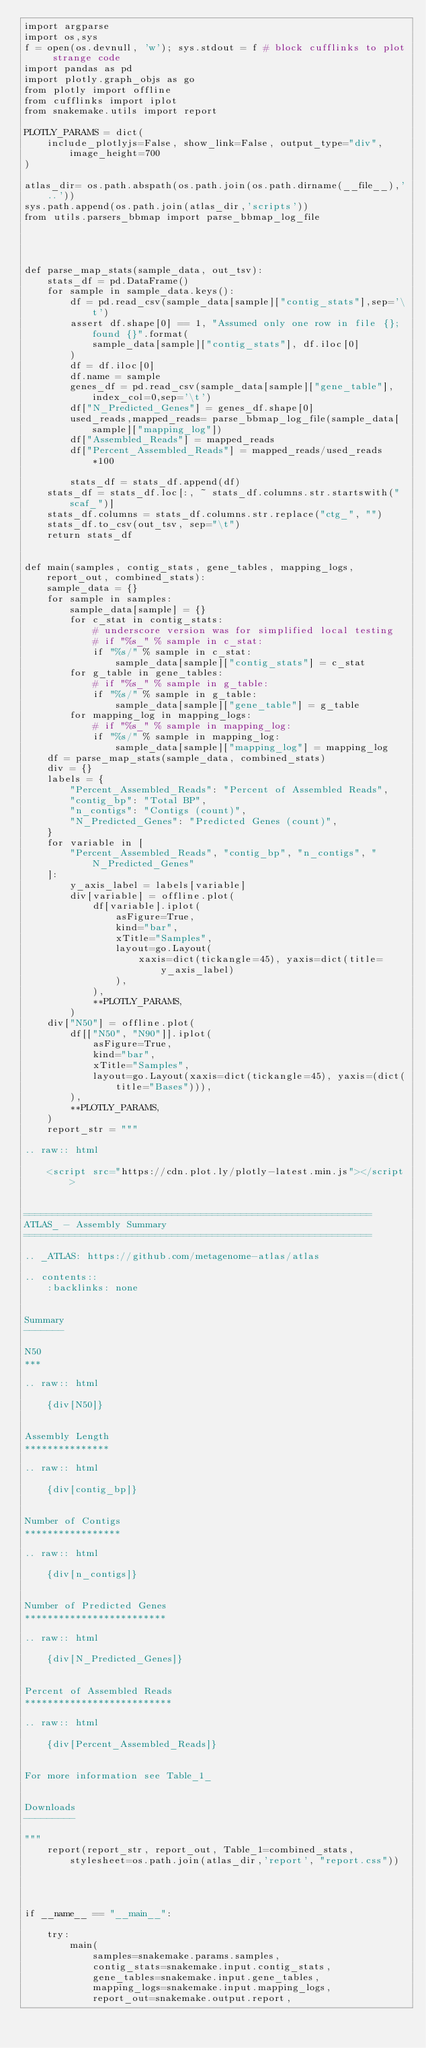Convert code to text. <code><loc_0><loc_0><loc_500><loc_500><_Python_>import argparse
import os,sys
f = open(os.devnull, 'w'); sys.stdout = f # block cufflinks to plot strange code
import pandas as pd
import plotly.graph_objs as go
from plotly import offline
from cufflinks import iplot
from snakemake.utils import report

PLOTLY_PARAMS = dict(
    include_plotlyjs=False, show_link=False, output_type="div", image_height=700
)

atlas_dir= os.path.abspath(os.path.join(os.path.dirname(__file__),'..'))
sys.path.append(os.path.join(atlas_dir,'scripts'))
from utils.parsers_bbmap import parse_bbmap_log_file




def parse_map_stats(sample_data, out_tsv):
    stats_df = pd.DataFrame()
    for sample in sample_data.keys():
        df = pd.read_csv(sample_data[sample]["contig_stats"],sep='\t')
        assert df.shape[0] == 1, "Assumed only one row in file {}; found {}".format(
            sample_data[sample]["contig_stats"], df.iloc[0]
        )
        df = df.iloc[0]
        df.name = sample
        genes_df = pd.read_csv(sample_data[sample]["gene_table"], index_col=0,sep='\t')
        df["N_Predicted_Genes"] = genes_df.shape[0]
        used_reads,mapped_reads= parse_bbmap_log_file(sample_data[sample]["mapping_log"])
        df["Assembled_Reads"] = mapped_reads
        df["Percent_Assembled_Reads"] = mapped_reads/used_reads *100

        stats_df = stats_df.append(df)
    stats_df = stats_df.loc[:, ~ stats_df.columns.str.startswith("scaf_")]
    stats_df.columns = stats_df.columns.str.replace("ctg_", "")
    stats_df.to_csv(out_tsv, sep="\t")
    return stats_df


def main(samples, contig_stats, gene_tables, mapping_logs, report_out, combined_stats):
    sample_data = {}
    for sample in samples:
        sample_data[sample] = {}
        for c_stat in contig_stats:
            # underscore version was for simplified local testing
            # if "%s_" % sample in c_stat:
            if "%s/" % sample in c_stat:
                sample_data[sample]["contig_stats"] = c_stat
        for g_table in gene_tables:
            # if "%s_" % sample in g_table:
            if "%s/" % sample in g_table:
                sample_data[sample]["gene_table"] = g_table
        for mapping_log in mapping_logs:
            # if "%s_" % sample in mapping_log:
            if "%s/" % sample in mapping_log:
                sample_data[sample]["mapping_log"] = mapping_log
    df = parse_map_stats(sample_data, combined_stats)
    div = {}
    labels = {
        "Percent_Assembled_Reads": "Percent of Assembled Reads",
        "contig_bp": "Total BP",
        "n_contigs": "Contigs (count)",
        "N_Predicted_Genes": "Predicted Genes (count)",
    }
    for variable in [
        "Percent_Assembled_Reads", "contig_bp", "n_contigs", "N_Predicted_Genes"
    ]:
        y_axis_label = labels[variable]
        div[variable] = offline.plot(
            df[variable].iplot(
                asFigure=True,
                kind="bar",
                xTitle="Samples",
                layout=go.Layout(
                    xaxis=dict(tickangle=45), yaxis=dict(title=y_axis_label)
                ),
            ),
            **PLOTLY_PARAMS,
        )
    div["N50"] = offline.plot(
        df[["N50", "N90"]].iplot(
            asFigure=True,
            kind="bar",
            xTitle="Samples",
            layout=go.Layout(xaxis=dict(tickangle=45), yaxis=(dict(title="Bases"))),
        ),
        **PLOTLY_PARAMS,
    )
    report_str = """

.. raw:: html

    <script src="https://cdn.plot.ly/plotly-latest.min.js"></script>


=============================================================
ATLAS_ - Assembly Summary
=============================================================

.. _ATLAS: https://github.com/metagenome-atlas/atlas

.. contents::
    :backlinks: none


Summary
-------

N50
***

.. raw:: html

    {div[N50]}


Assembly Length
***************

.. raw:: html

    {div[contig_bp]}


Number of Contigs
*****************

.. raw:: html

    {div[n_contigs]}


Number of Predicted Genes
*************************

.. raw:: html

    {div[N_Predicted_Genes]}


Percent of Assembled Reads
**************************

.. raw:: html

    {div[Percent_Assembled_Reads]}


For more information see Table_1_


Downloads
---------

"""
    report(report_str, report_out, Table_1=combined_stats, stylesheet=os.path.join(atlas_dir,'report', "report.css"))




if __name__ == "__main__":

    try:
        main(
            samples=snakemake.params.samples,
            contig_stats=snakemake.input.contig_stats,
            gene_tables=snakemake.input.gene_tables,
            mapping_logs=snakemake.input.mapping_logs,
            report_out=snakemake.output.report,</code> 